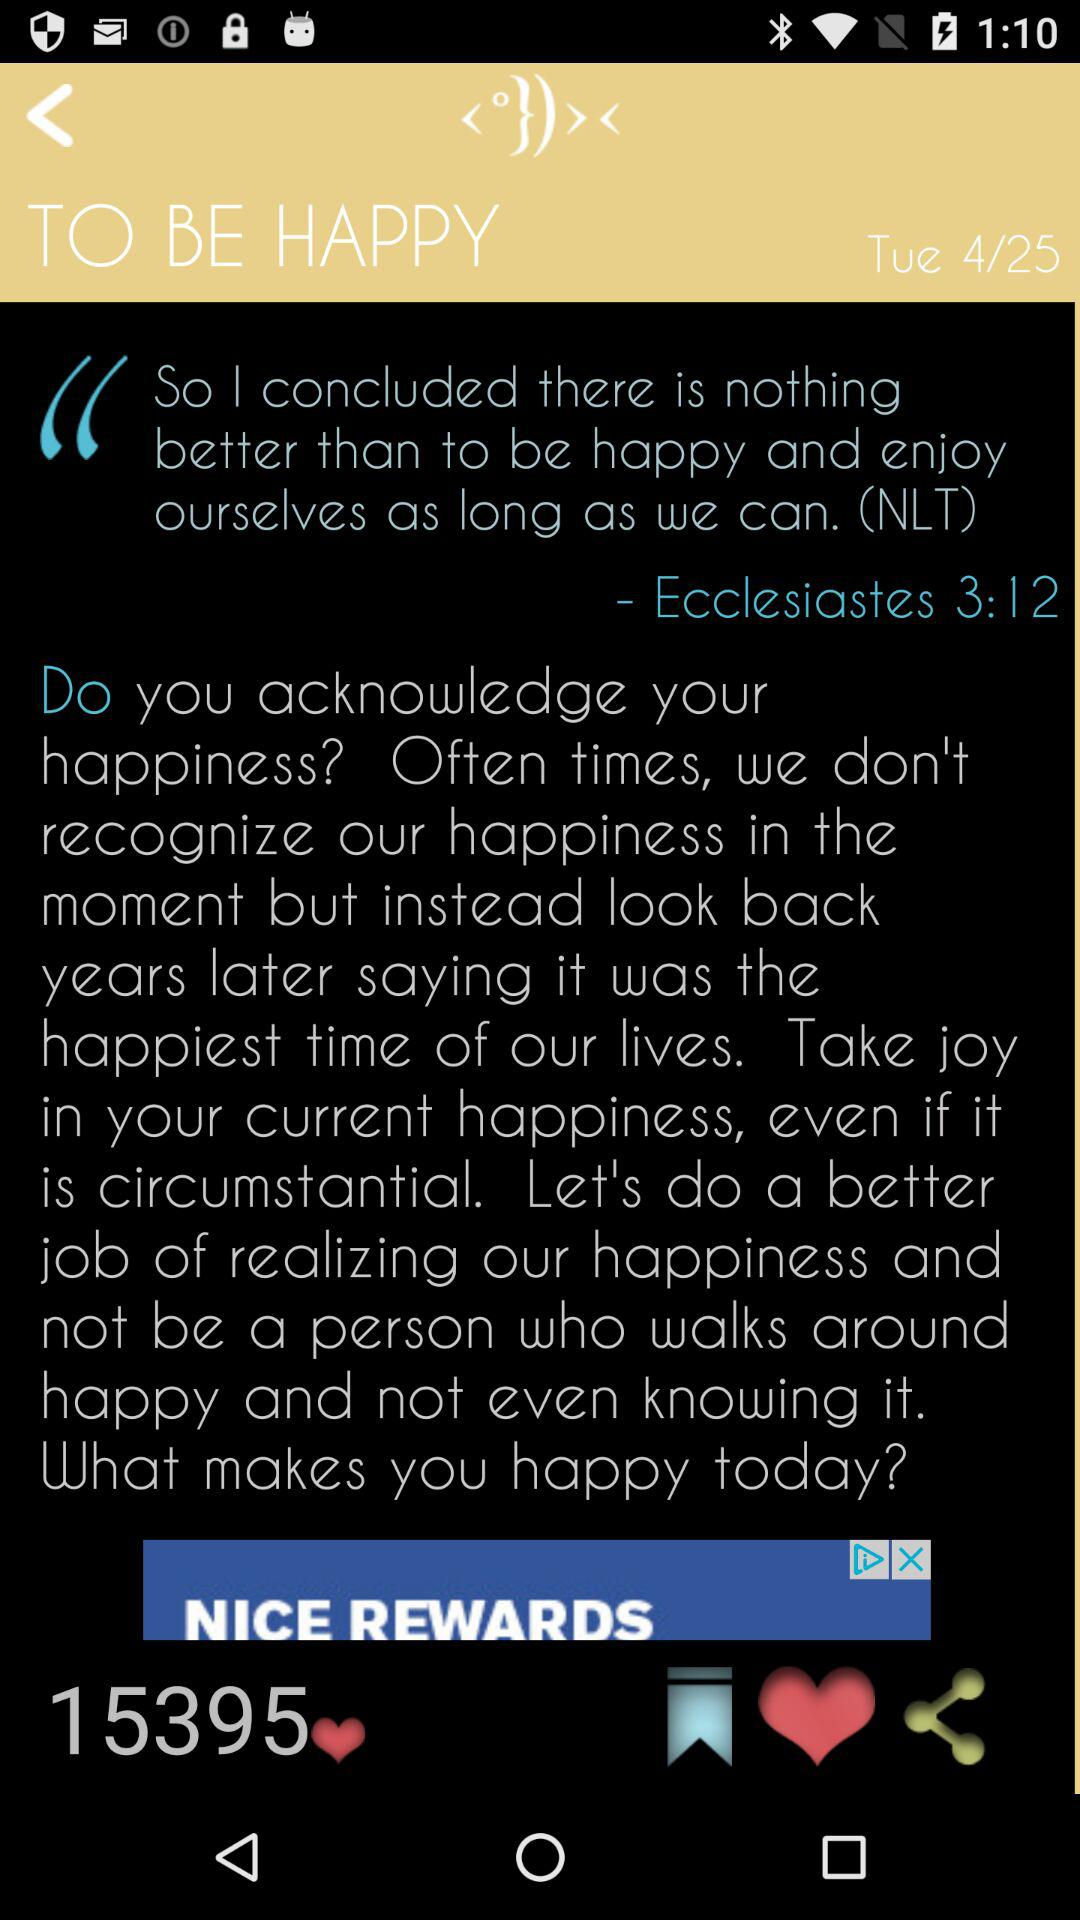How many likes are there? There are 15395 likes. 